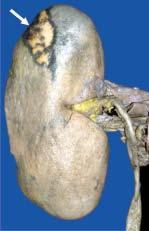s wide base on the surface?
Answer the question using a single word or phrase. No 